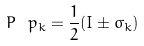Convert formula to latex. <formula><loc_0><loc_0><loc_500><loc_500>P \ p _ { k } = \frac { 1 } { 2 } ( I \pm \sigma _ { k } )</formula> 